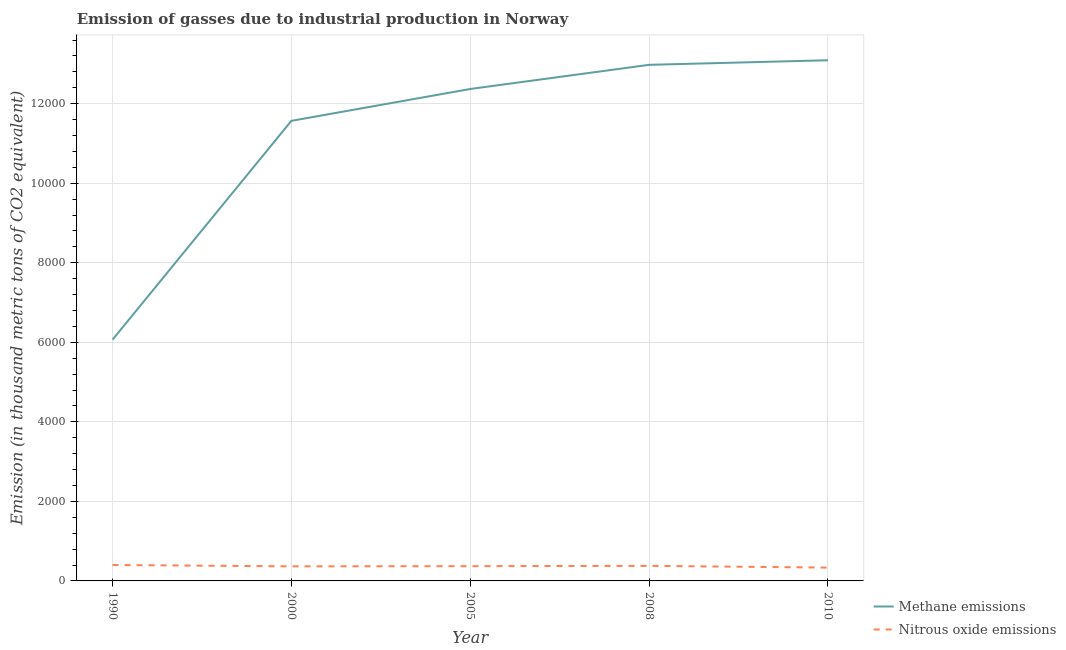How many different coloured lines are there?
Make the answer very short. 2. Does the line corresponding to amount of methane emissions intersect with the line corresponding to amount of nitrous oxide emissions?
Offer a terse response. No. Is the number of lines equal to the number of legend labels?
Make the answer very short. Yes. What is the amount of nitrous oxide emissions in 2008?
Your answer should be compact. 378.9. Across all years, what is the maximum amount of methane emissions?
Ensure brevity in your answer.  1.31e+04. Across all years, what is the minimum amount of methane emissions?
Give a very brief answer. 6065.9. In which year was the amount of methane emissions maximum?
Your answer should be very brief. 2010. What is the total amount of methane emissions in the graph?
Offer a very short reply. 5.61e+04. What is the difference between the amount of methane emissions in 1990 and that in 2000?
Your response must be concise. -5501.9. What is the difference between the amount of methane emissions in 2008 and the amount of nitrous oxide emissions in 2005?
Provide a succinct answer. 1.26e+04. What is the average amount of methane emissions per year?
Offer a terse response. 1.12e+04. In the year 1990, what is the difference between the amount of methane emissions and amount of nitrous oxide emissions?
Give a very brief answer. 5665.5. In how many years, is the amount of nitrous oxide emissions greater than 12800 thousand metric tons?
Your response must be concise. 0. What is the ratio of the amount of methane emissions in 2005 to that in 2008?
Make the answer very short. 0.95. Is the difference between the amount of methane emissions in 1990 and 2005 greater than the difference between the amount of nitrous oxide emissions in 1990 and 2005?
Keep it short and to the point. No. What is the difference between the highest and the second highest amount of methane emissions?
Give a very brief answer. 115.3. What is the difference between the highest and the lowest amount of nitrous oxide emissions?
Offer a very short reply. 65.3. Is the sum of the amount of nitrous oxide emissions in 2005 and 2010 greater than the maximum amount of methane emissions across all years?
Keep it short and to the point. No. Does the amount of methane emissions monotonically increase over the years?
Offer a terse response. Yes. Is the amount of methane emissions strictly greater than the amount of nitrous oxide emissions over the years?
Your answer should be compact. Yes. How many lines are there?
Your response must be concise. 2. What is the difference between two consecutive major ticks on the Y-axis?
Your answer should be compact. 2000. Are the values on the major ticks of Y-axis written in scientific E-notation?
Offer a terse response. No. Does the graph contain any zero values?
Offer a very short reply. No. How many legend labels are there?
Your answer should be compact. 2. What is the title of the graph?
Offer a very short reply. Emission of gasses due to industrial production in Norway. What is the label or title of the Y-axis?
Offer a terse response. Emission (in thousand metric tons of CO2 equivalent). What is the Emission (in thousand metric tons of CO2 equivalent) in Methane emissions in 1990?
Keep it short and to the point. 6065.9. What is the Emission (in thousand metric tons of CO2 equivalent) in Nitrous oxide emissions in 1990?
Offer a terse response. 400.4. What is the Emission (in thousand metric tons of CO2 equivalent) in Methane emissions in 2000?
Give a very brief answer. 1.16e+04. What is the Emission (in thousand metric tons of CO2 equivalent) in Nitrous oxide emissions in 2000?
Offer a terse response. 366.4. What is the Emission (in thousand metric tons of CO2 equivalent) in Methane emissions in 2005?
Offer a very short reply. 1.24e+04. What is the Emission (in thousand metric tons of CO2 equivalent) in Nitrous oxide emissions in 2005?
Your response must be concise. 370.7. What is the Emission (in thousand metric tons of CO2 equivalent) in Methane emissions in 2008?
Offer a terse response. 1.30e+04. What is the Emission (in thousand metric tons of CO2 equivalent) in Nitrous oxide emissions in 2008?
Keep it short and to the point. 378.9. What is the Emission (in thousand metric tons of CO2 equivalent) in Methane emissions in 2010?
Offer a very short reply. 1.31e+04. What is the Emission (in thousand metric tons of CO2 equivalent) of Nitrous oxide emissions in 2010?
Ensure brevity in your answer.  335.1. Across all years, what is the maximum Emission (in thousand metric tons of CO2 equivalent) in Methane emissions?
Ensure brevity in your answer.  1.31e+04. Across all years, what is the maximum Emission (in thousand metric tons of CO2 equivalent) of Nitrous oxide emissions?
Give a very brief answer. 400.4. Across all years, what is the minimum Emission (in thousand metric tons of CO2 equivalent) of Methane emissions?
Your answer should be very brief. 6065.9. Across all years, what is the minimum Emission (in thousand metric tons of CO2 equivalent) of Nitrous oxide emissions?
Keep it short and to the point. 335.1. What is the total Emission (in thousand metric tons of CO2 equivalent) in Methane emissions in the graph?
Provide a short and direct response. 5.61e+04. What is the total Emission (in thousand metric tons of CO2 equivalent) of Nitrous oxide emissions in the graph?
Make the answer very short. 1851.5. What is the difference between the Emission (in thousand metric tons of CO2 equivalent) in Methane emissions in 1990 and that in 2000?
Keep it short and to the point. -5501.9. What is the difference between the Emission (in thousand metric tons of CO2 equivalent) of Methane emissions in 1990 and that in 2005?
Provide a short and direct response. -6302.9. What is the difference between the Emission (in thousand metric tons of CO2 equivalent) in Nitrous oxide emissions in 1990 and that in 2005?
Your response must be concise. 29.7. What is the difference between the Emission (in thousand metric tons of CO2 equivalent) in Methane emissions in 1990 and that in 2008?
Offer a terse response. -6910.1. What is the difference between the Emission (in thousand metric tons of CO2 equivalent) in Methane emissions in 1990 and that in 2010?
Provide a succinct answer. -7025.4. What is the difference between the Emission (in thousand metric tons of CO2 equivalent) in Nitrous oxide emissions in 1990 and that in 2010?
Provide a short and direct response. 65.3. What is the difference between the Emission (in thousand metric tons of CO2 equivalent) of Methane emissions in 2000 and that in 2005?
Ensure brevity in your answer.  -801. What is the difference between the Emission (in thousand metric tons of CO2 equivalent) in Methane emissions in 2000 and that in 2008?
Provide a succinct answer. -1408.2. What is the difference between the Emission (in thousand metric tons of CO2 equivalent) in Nitrous oxide emissions in 2000 and that in 2008?
Ensure brevity in your answer.  -12.5. What is the difference between the Emission (in thousand metric tons of CO2 equivalent) in Methane emissions in 2000 and that in 2010?
Ensure brevity in your answer.  -1523.5. What is the difference between the Emission (in thousand metric tons of CO2 equivalent) of Nitrous oxide emissions in 2000 and that in 2010?
Make the answer very short. 31.3. What is the difference between the Emission (in thousand metric tons of CO2 equivalent) of Methane emissions in 2005 and that in 2008?
Make the answer very short. -607.2. What is the difference between the Emission (in thousand metric tons of CO2 equivalent) of Methane emissions in 2005 and that in 2010?
Offer a terse response. -722.5. What is the difference between the Emission (in thousand metric tons of CO2 equivalent) in Nitrous oxide emissions in 2005 and that in 2010?
Your answer should be very brief. 35.6. What is the difference between the Emission (in thousand metric tons of CO2 equivalent) in Methane emissions in 2008 and that in 2010?
Your answer should be compact. -115.3. What is the difference between the Emission (in thousand metric tons of CO2 equivalent) of Nitrous oxide emissions in 2008 and that in 2010?
Give a very brief answer. 43.8. What is the difference between the Emission (in thousand metric tons of CO2 equivalent) in Methane emissions in 1990 and the Emission (in thousand metric tons of CO2 equivalent) in Nitrous oxide emissions in 2000?
Ensure brevity in your answer.  5699.5. What is the difference between the Emission (in thousand metric tons of CO2 equivalent) in Methane emissions in 1990 and the Emission (in thousand metric tons of CO2 equivalent) in Nitrous oxide emissions in 2005?
Ensure brevity in your answer.  5695.2. What is the difference between the Emission (in thousand metric tons of CO2 equivalent) in Methane emissions in 1990 and the Emission (in thousand metric tons of CO2 equivalent) in Nitrous oxide emissions in 2008?
Ensure brevity in your answer.  5687. What is the difference between the Emission (in thousand metric tons of CO2 equivalent) in Methane emissions in 1990 and the Emission (in thousand metric tons of CO2 equivalent) in Nitrous oxide emissions in 2010?
Offer a terse response. 5730.8. What is the difference between the Emission (in thousand metric tons of CO2 equivalent) of Methane emissions in 2000 and the Emission (in thousand metric tons of CO2 equivalent) of Nitrous oxide emissions in 2005?
Your response must be concise. 1.12e+04. What is the difference between the Emission (in thousand metric tons of CO2 equivalent) in Methane emissions in 2000 and the Emission (in thousand metric tons of CO2 equivalent) in Nitrous oxide emissions in 2008?
Your response must be concise. 1.12e+04. What is the difference between the Emission (in thousand metric tons of CO2 equivalent) in Methane emissions in 2000 and the Emission (in thousand metric tons of CO2 equivalent) in Nitrous oxide emissions in 2010?
Keep it short and to the point. 1.12e+04. What is the difference between the Emission (in thousand metric tons of CO2 equivalent) of Methane emissions in 2005 and the Emission (in thousand metric tons of CO2 equivalent) of Nitrous oxide emissions in 2008?
Provide a succinct answer. 1.20e+04. What is the difference between the Emission (in thousand metric tons of CO2 equivalent) in Methane emissions in 2005 and the Emission (in thousand metric tons of CO2 equivalent) in Nitrous oxide emissions in 2010?
Give a very brief answer. 1.20e+04. What is the difference between the Emission (in thousand metric tons of CO2 equivalent) of Methane emissions in 2008 and the Emission (in thousand metric tons of CO2 equivalent) of Nitrous oxide emissions in 2010?
Give a very brief answer. 1.26e+04. What is the average Emission (in thousand metric tons of CO2 equivalent) of Methane emissions per year?
Ensure brevity in your answer.  1.12e+04. What is the average Emission (in thousand metric tons of CO2 equivalent) of Nitrous oxide emissions per year?
Give a very brief answer. 370.3. In the year 1990, what is the difference between the Emission (in thousand metric tons of CO2 equivalent) in Methane emissions and Emission (in thousand metric tons of CO2 equivalent) in Nitrous oxide emissions?
Keep it short and to the point. 5665.5. In the year 2000, what is the difference between the Emission (in thousand metric tons of CO2 equivalent) of Methane emissions and Emission (in thousand metric tons of CO2 equivalent) of Nitrous oxide emissions?
Ensure brevity in your answer.  1.12e+04. In the year 2005, what is the difference between the Emission (in thousand metric tons of CO2 equivalent) of Methane emissions and Emission (in thousand metric tons of CO2 equivalent) of Nitrous oxide emissions?
Give a very brief answer. 1.20e+04. In the year 2008, what is the difference between the Emission (in thousand metric tons of CO2 equivalent) of Methane emissions and Emission (in thousand metric tons of CO2 equivalent) of Nitrous oxide emissions?
Your answer should be compact. 1.26e+04. In the year 2010, what is the difference between the Emission (in thousand metric tons of CO2 equivalent) of Methane emissions and Emission (in thousand metric tons of CO2 equivalent) of Nitrous oxide emissions?
Your response must be concise. 1.28e+04. What is the ratio of the Emission (in thousand metric tons of CO2 equivalent) of Methane emissions in 1990 to that in 2000?
Your answer should be compact. 0.52. What is the ratio of the Emission (in thousand metric tons of CO2 equivalent) in Nitrous oxide emissions in 1990 to that in 2000?
Ensure brevity in your answer.  1.09. What is the ratio of the Emission (in thousand metric tons of CO2 equivalent) in Methane emissions in 1990 to that in 2005?
Offer a terse response. 0.49. What is the ratio of the Emission (in thousand metric tons of CO2 equivalent) in Nitrous oxide emissions in 1990 to that in 2005?
Provide a succinct answer. 1.08. What is the ratio of the Emission (in thousand metric tons of CO2 equivalent) of Methane emissions in 1990 to that in 2008?
Your answer should be compact. 0.47. What is the ratio of the Emission (in thousand metric tons of CO2 equivalent) in Nitrous oxide emissions in 1990 to that in 2008?
Provide a succinct answer. 1.06. What is the ratio of the Emission (in thousand metric tons of CO2 equivalent) of Methane emissions in 1990 to that in 2010?
Offer a very short reply. 0.46. What is the ratio of the Emission (in thousand metric tons of CO2 equivalent) in Nitrous oxide emissions in 1990 to that in 2010?
Your response must be concise. 1.19. What is the ratio of the Emission (in thousand metric tons of CO2 equivalent) in Methane emissions in 2000 to that in 2005?
Offer a terse response. 0.94. What is the ratio of the Emission (in thousand metric tons of CO2 equivalent) in Nitrous oxide emissions in 2000 to that in 2005?
Keep it short and to the point. 0.99. What is the ratio of the Emission (in thousand metric tons of CO2 equivalent) in Methane emissions in 2000 to that in 2008?
Give a very brief answer. 0.89. What is the ratio of the Emission (in thousand metric tons of CO2 equivalent) of Nitrous oxide emissions in 2000 to that in 2008?
Make the answer very short. 0.97. What is the ratio of the Emission (in thousand metric tons of CO2 equivalent) of Methane emissions in 2000 to that in 2010?
Keep it short and to the point. 0.88. What is the ratio of the Emission (in thousand metric tons of CO2 equivalent) of Nitrous oxide emissions in 2000 to that in 2010?
Offer a terse response. 1.09. What is the ratio of the Emission (in thousand metric tons of CO2 equivalent) in Methane emissions in 2005 to that in 2008?
Make the answer very short. 0.95. What is the ratio of the Emission (in thousand metric tons of CO2 equivalent) in Nitrous oxide emissions in 2005 to that in 2008?
Offer a terse response. 0.98. What is the ratio of the Emission (in thousand metric tons of CO2 equivalent) of Methane emissions in 2005 to that in 2010?
Give a very brief answer. 0.94. What is the ratio of the Emission (in thousand metric tons of CO2 equivalent) of Nitrous oxide emissions in 2005 to that in 2010?
Provide a succinct answer. 1.11. What is the ratio of the Emission (in thousand metric tons of CO2 equivalent) of Methane emissions in 2008 to that in 2010?
Your answer should be very brief. 0.99. What is the ratio of the Emission (in thousand metric tons of CO2 equivalent) of Nitrous oxide emissions in 2008 to that in 2010?
Offer a very short reply. 1.13. What is the difference between the highest and the second highest Emission (in thousand metric tons of CO2 equivalent) in Methane emissions?
Provide a short and direct response. 115.3. What is the difference between the highest and the lowest Emission (in thousand metric tons of CO2 equivalent) in Methane emissions?
Provide a short and direct response. 7025.4. What is the difference between the highest and the lowest Emission (in thousand metric tons of CO2 equivalent) in Nitrous oxide emissions?
Your answer should be very brief. 65.3. 